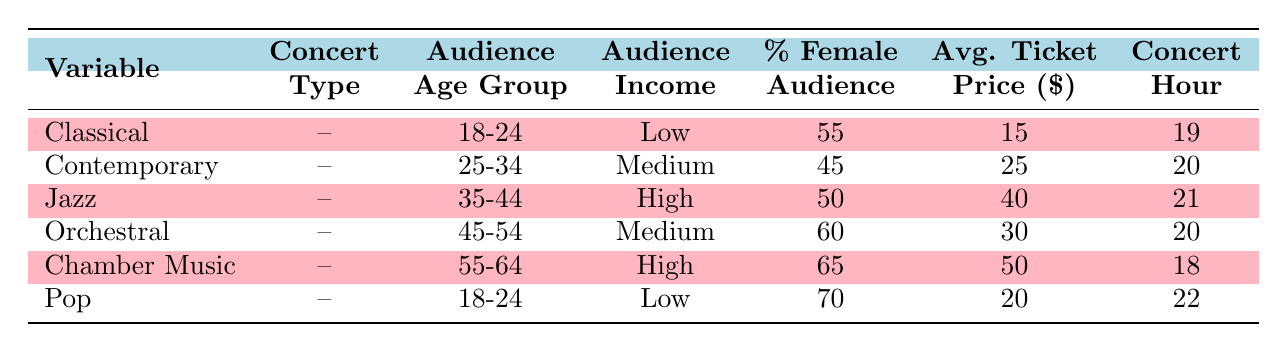What is the average ticket price for Classical concerts? From the table, we can see that the average ticket price for Classical concerts is listed as 15.
Answer: 15 How many concert types have an audience age group of 18-24? By examining the table, we can find that both Classical and Pop concert types have the audience age group of 18-24. Therefore, there are a total of 2 concert types.
Answer: 2 Is the percentage of female audience higher for Orchestral concerts than for Contemporary concerts? Looking at the table, Orchestral concerts have a 60% female audience, while Contemporary concerts have a 45% female audience. Since 60% is greater than 45%, the statement is true.
Answer: Yes What concert type has the highest percentage of female audience? From the table, Chamber Music has the highest percentage of female audience at 65%.
Answer: Chamber Music What is the relationship between average ticket price and audience income level? In general, as income levels increase (from Low to Medium to High), we can observe that the average ticket prices also tend to increase (15 for Low, 25 for Medium, and 40/50 for High). This suggests a positive correlation between average ticket price and audience income level.
Answer: Positive correlation Which concert type starts the earliest and what is the hour of that concert? The earliest starting concert can be found in the Hour of Concert column. Chamber Music has a concert hour of 18, which is the earliest compared to the others.
Answer: Chamber Music at hour 18 Are there any concert types that target the same audience age group? By reviewing the audience age groups across different concert types, we notice that there are two concert types (Classical and Pop) targeting the 18-24 age group. Thus, yes, there are concert types that target the same age group.
Answer: Yes What is the average ticket price for the 25-34 age group? The only concert type targeting the 25-34 age group is Contemporary. From the table, the average ticket price is 25.
Answer: 25 If we compare the Jazz and Chamber Music concerts, which one has a lower average ticket price and by how much? Jazz has an average ticket price of 40, while Chamber Music has 50. There is a difference of 10 in the average ticket prices, where Jazz's price is lower.
Answer: Jazz, by 10 